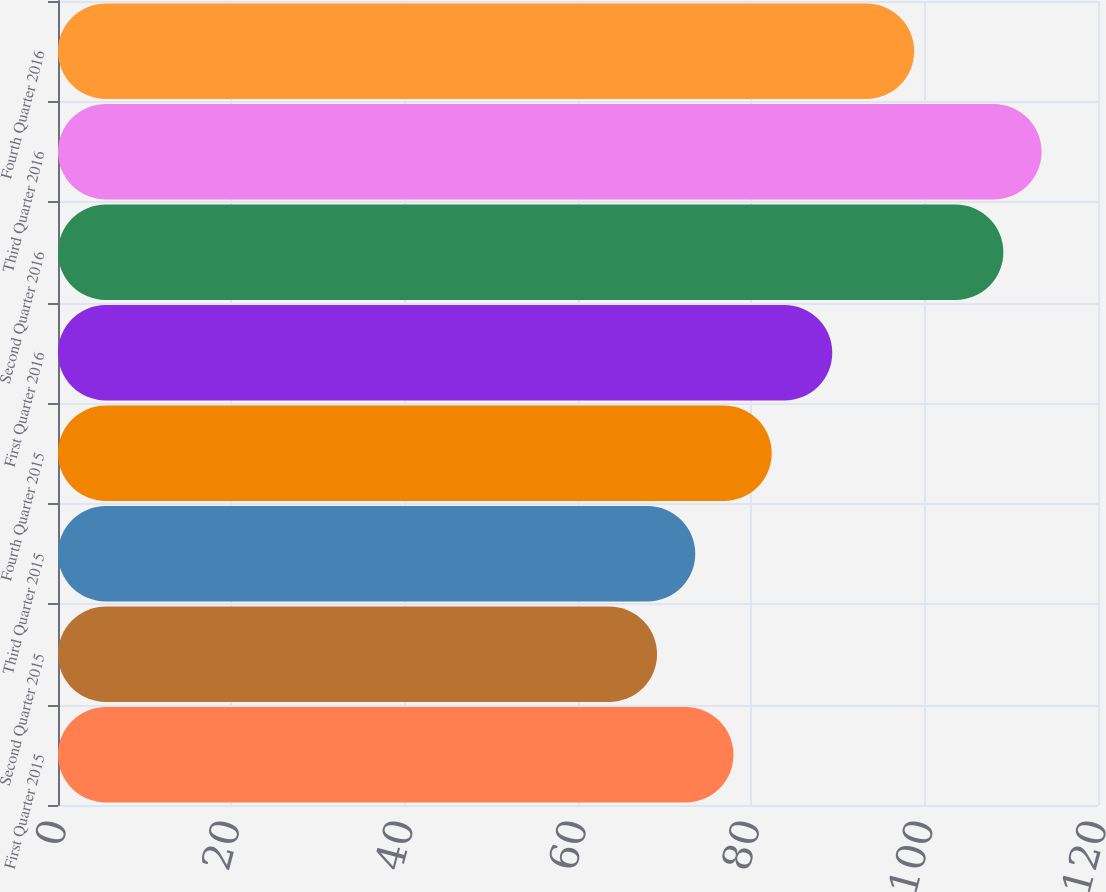<chart> <loc_0><loc_0><loc_500><loc_500><bar_chart><fcel>First Quarter 2015<fcel>Second Quarter 2015<fcel>Third Quarter 2015<fcel>Fourth Quarter 2015<fcel>First Quarter 2016<fcel>Second Quarter 2016<fcel>Third Quarter 2016<fcel>Fourth Quarter 2016<nl><fcel>77.94<fcel>69.12<fcel>73.53<fcel>82.35<fcel>89.34<fcel>109.08<fcel>113.49<fcel>98.79<nl></chart> 